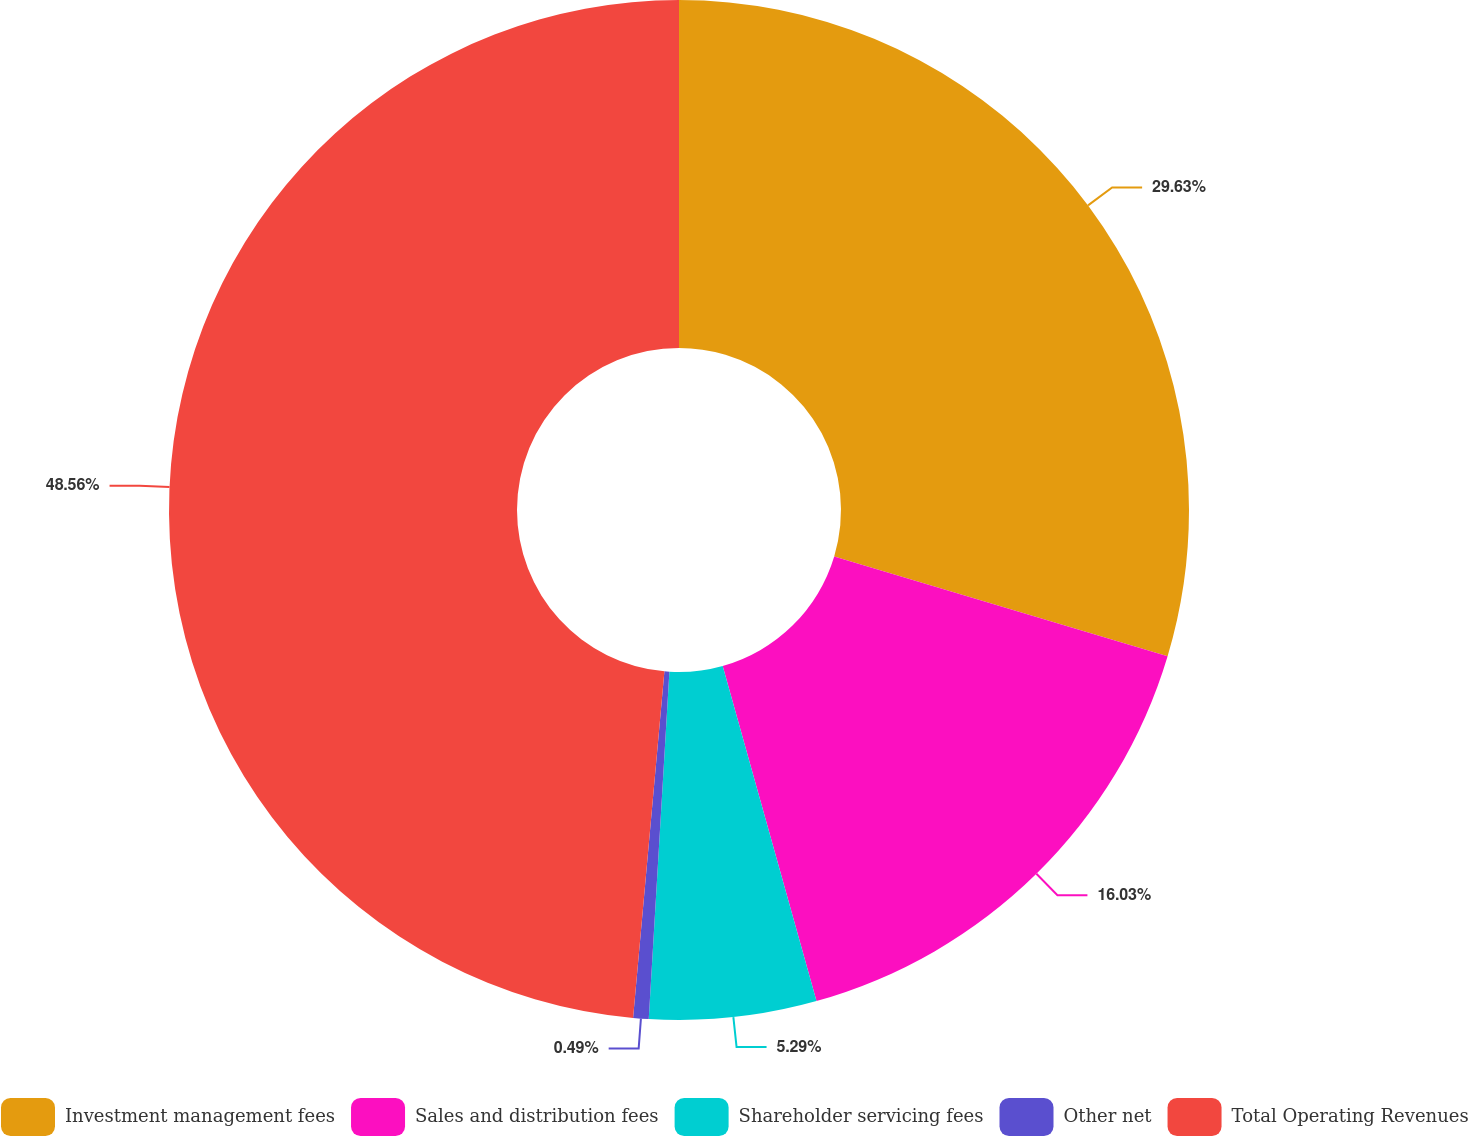Convert chart. <chart><loc_0><loc_0><loc_500><loc_500><pie_chart><fcel>Investment management fees<fcel>Sales and distribution fees<fcel>Shareholder servicing fees<fcel>Other net<fcel>Total Operating Revenues<nl><fcel>29.63%<fcel>16.03%<fcel>5.29%<fcel>0.49%<fcel>48.57%<nl></chart> 